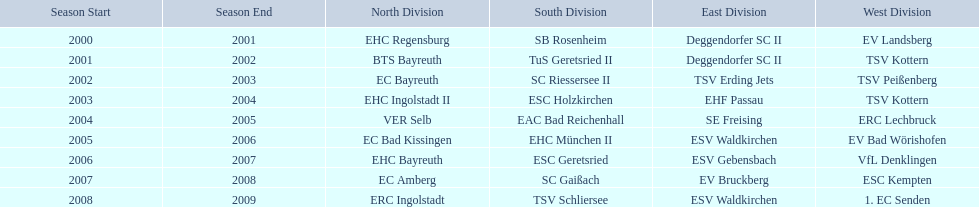What is the number of seasons covered in the table? 9. 